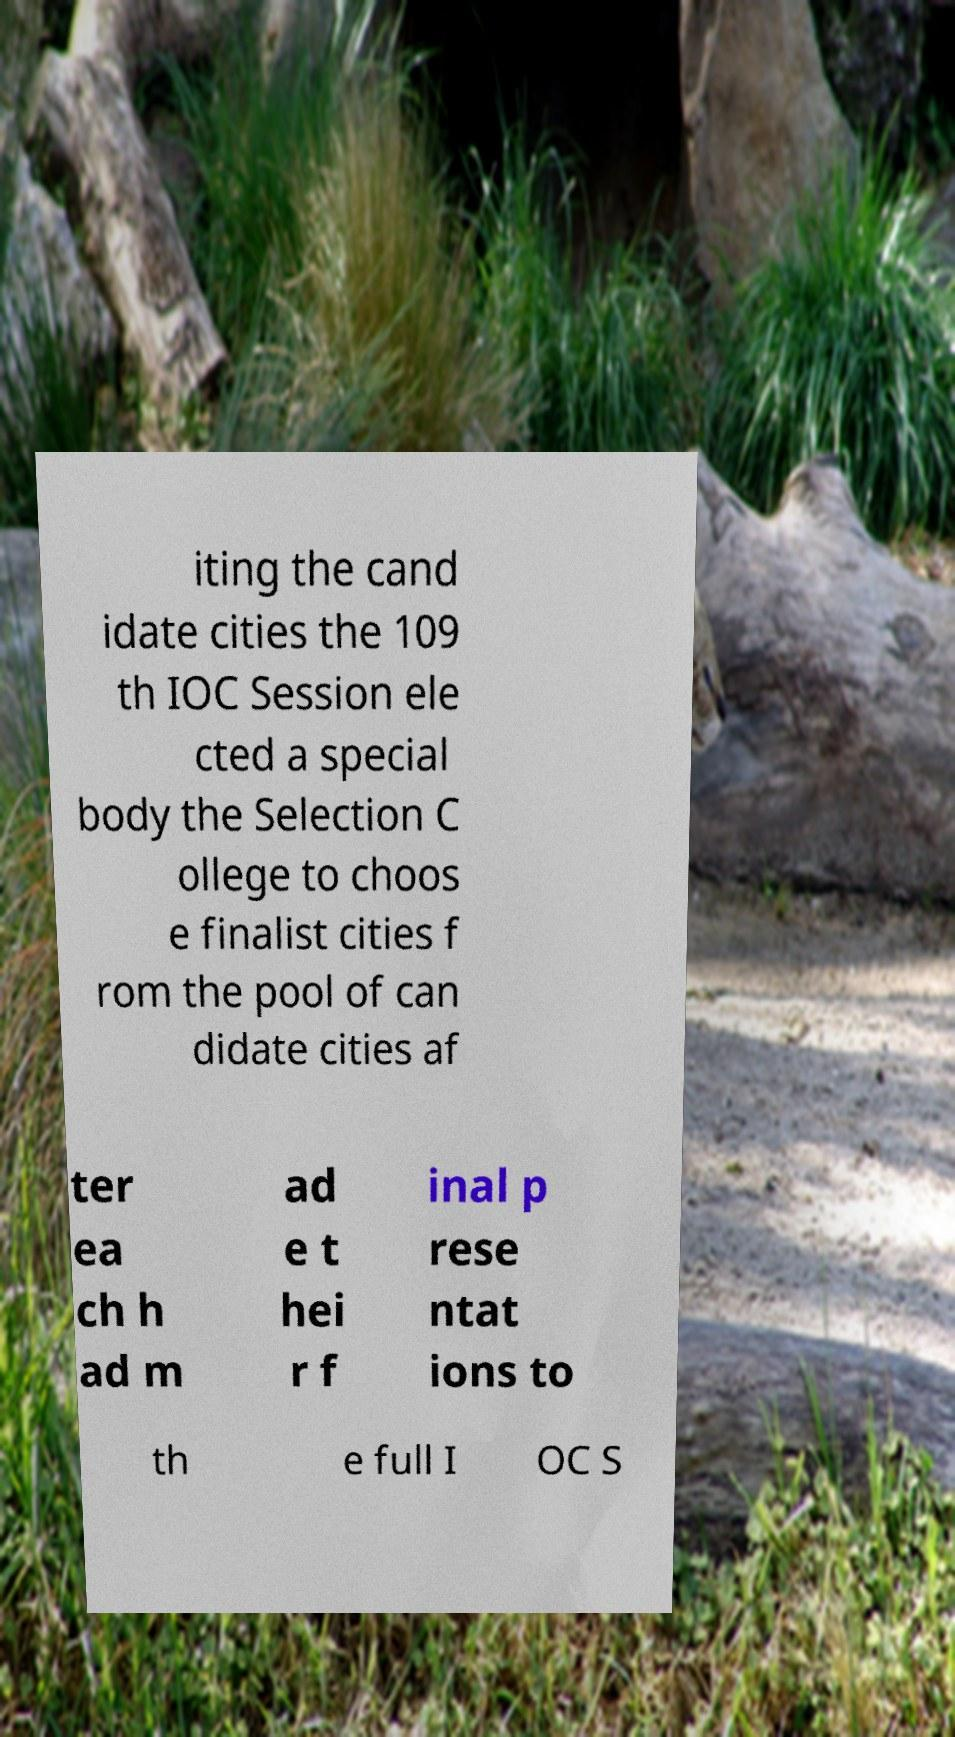I need the written content from this picture converted into text. Can you do that? iting the cand idate cities the 109 th IOC Session ele cted a special body the Selection C ollege to choos e finalist cities f rom the pool of can didate cities af ter ea ch h ad m ad e t hei r f inal p rese ntat ions to th e full I OC S 